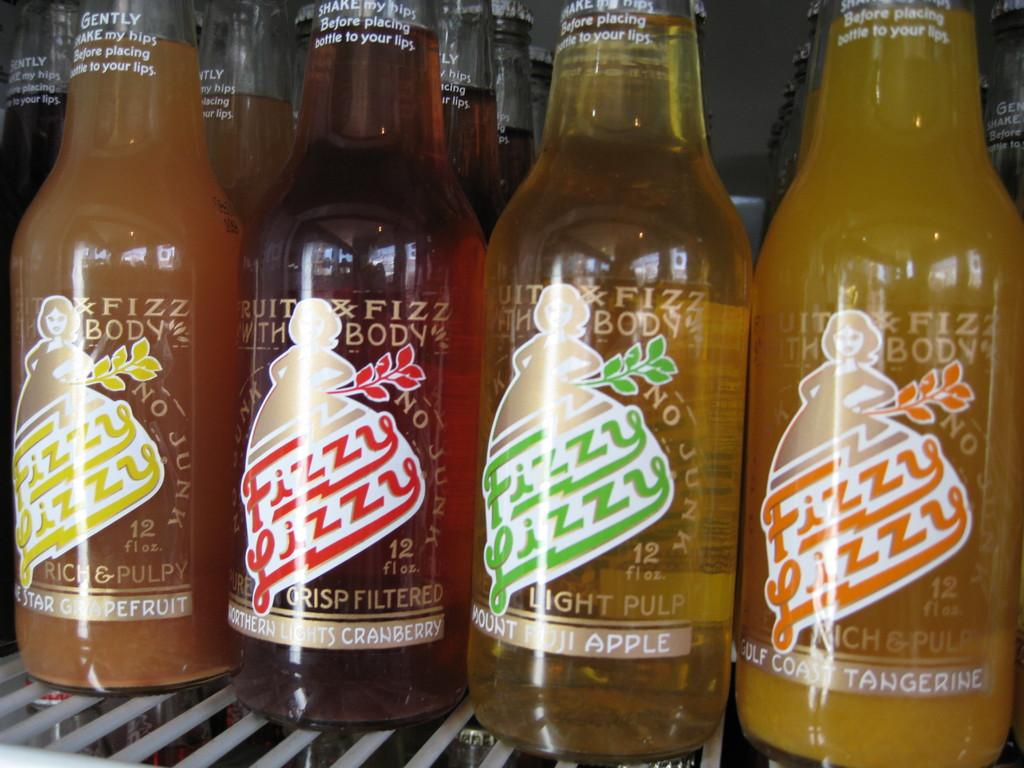<image>
Share a concise interpretation of the image provided. Different flavors of Fizzy Lizzy soft drinks are lined up. 